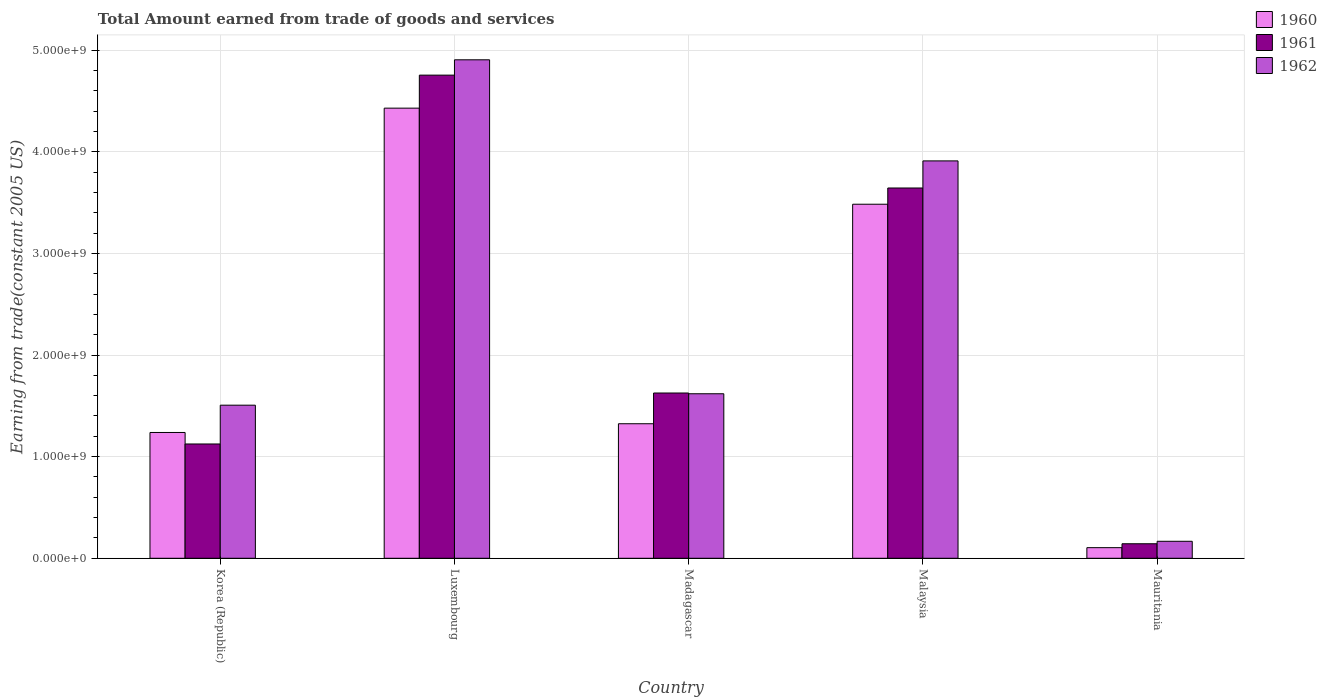How many different coloured bars are there?
Your answer should be very brief. 3. Are the number of bars on each tick of the X-axis equal?
Give a very brief answer. Yes. How many bars are there on the 5th tick from the right?
Ensure brevity in your answer.  3. What is the total amount earned by trading goods and services in 1961 in Madagascar?
Make the answer very short. 1.63e+09. Across all countries, what is the maximum total amount earned by trading goods and services in 1960?
Ensure brevity in your answer.  4.43e+09. Across all countries, what is the minimum total amount earned by trading goods and services in 1960?
Your response must be concise. 1.04e+08. In which country was the total amount earned by trading goods and services in 1961 maximum?
Make the answer very short. Luxembourg. In which country was the total amount earned by trading goods and services in 1962 minimum?
Provide a short and direct response. Mauritania. What is the total total amount earned by trading goods and services in 1961 in the graph?
Provide a succinct answer. 1.13e+1. What is the difference between the total amount earned by trading goods and services in 1962 in Korea (Republic) and that in Mauritania?
Offer a terse response. 1.34e+09. What is the difference between the total amount earned by trading goods and services in 1961 in Mauritania and the total amount earned by trading goods and services in 1962 in Luxembourg?
Offer a very short reply. -4.76e+09. What is the average total amount earned by trading goods and services in 1961 per country?
Keep it short and to the point. 2.26e+09. What is the difference between the total amount earned by trading goods and services of/in 1961 and total amount earned by trading goods and services of/in 1962 in Malaysia?
Your answer should be compact. -2.67e+08. In how many countries, is the total amount earned by trading goods and services in 1960 greater than 4400000000 US$?
Offer a terse response. 1. What is the ratio of the total amount earned by trading goods and services in 1962 in Korea (Republic) to that in Madagascar?
Ensure brevity in your answer.  0.93. Is the total amount earned by trading goods and services in 1960 in Luxembourg less than that in Mauritania?
Make the answer very short. No. Is the difference between the total amount earned by trading goods and services in 1961 in Madagascar and Mauritania greater than the difference between the total amount earned by trading goods and services in 1962 in Madagascar and Mauritania?
Ensure brevity in your answer.  Yes. What is the difference between the highest and the second highest total amount earned by trading goods and services in 1960?
Keep it short and to the point. -9.45e+08. What is the difference between the highest and the lowest total amount earned by trading goods and services in 1960?
Offer a very short reply. 4.32e+09. In how many countries, is the total amount earned by trading goods and services in 1961 greater than the average total amount earned by trading goods and services in 1961 taken over all countries?
Make the answer very short. 2. Is the sum of the total amount earned by trading goods and services in 1960 in Korea (Republic) and Luxembourg greater than the maximum total amount earned by trading goods and services in 1962 across all countries?
Your response must be concise. Yes. What does the 2nd bar from the right in Madagascar represents?
Give a very brief answer. 1961. Is it the case that in every country, the sum of the total amount earned by trading goods and services in 1960 and total amount earned by trading goods and services in 1961 is greater than the total amount earned by trading goods and services in 1962?
Keep it short and to the point. Yes. How many bars are there?
Make the answer very short. 15. Are all the bars in the graph horizontal?
Offer a terse response. No. How many countries are there in the graph?
Keep it short and to the point. 5. Where does the legend appear in the graph?
Provide a short and direct response. Top right. How are the legend labels stacked?
Your answer should be compact. Vertical. What is the title of the graph?
Your answer should be very brief. Total Amount earned from trade of goods and services. Does "1998" appear as one of the legend labels in the graph?
Give a very brief answer. No. What is the label or title of the X-axis?
Make the answer very short. Country. What is the label or title of the Y-axis?
Provide a succinct answer. Earning from trade(constant 2005 US). What is the Earning from trade(constant 2005 US) of 1960 in Korea (Republic)?
Provide a succinct answer. 1.24e+09. What is the Earning from trade(constant 2005 US) of 1961 in Korea (Republic)?
Your answer should be compact. 1.12e+09. What is the Earning from trade(constant 2005 US) in 1962 in Korea (Republic)?
Your answer should be very brief. 1.51e+09. What is the Earning from trade(constant 2005 US) of 1960 in Luxembourg?
Make the answer very short. 4.43e+09. What is the Earning from trade(constant 2005 US) of 1961 in Luxembourg?
Ensure brevity in your answer.  4.75e+09. What is the Earning from trade(constant 2005 US) in 1962 in Luxembourg?
Give a very brief answer. 4.90e+09. What is the Earning from trade(constant 2005 US) of 1960 in Madagascar?
Offer a terse response. 1.32e+09. What is the Earning from trade(constant 2005 US) of 1961 in Madagascar?
Make the answer very short. 1.63e+09. What is the Earning from trade(constant 2005 US) in 1962 in Madagascar?
Your response must be concise. 1.62e+09. What is the Earning from trade(constant 2005 US) in 1960 in Malaysia?
Offer a very short reply. 3.48e+09. What is the Earning from trade(constant 2005 US) of 1961 in Malaysia?
Your answer should be very brief. 3.64e+09. What is the Earning from trade(constant 2005 US) in 1962 in Malaysia?
Give a very brief answer. 3.91e+09. What is the Earning from trade(constant 2005 US) of 1960 in Mauritania?
Your response must be concise. 1.04e+08. What is the Earning from trade(constant 2005 US) in 1961 in Mauritania?
Provide a succinct answer. 1.43e+08. What is the Earning from trade(constant 2005 US) in 1962 in Mauritania?
Keep it short and to the point. 1.67e+08. Across all countries, what is the maximum Earning from trade(constant 2005 US) of 1960?
Your response must be concise. 4.43e+09. Across all countries, what is the maximum Earning from trade(constant 2005 US) of 1961?
Your answer should be compact. 4.75e+09. Across all countries, what is the maximum Earning from trade(constant 2005 US) of 1962?
Offer a terse response. 4.90e+09. Across all countries, what is the minimum Earning from trade(constant 2005 US) in 1960?
Ensure brevity in your answer.  1.04e+08. Across all countries, what is the minimum Earning from trade(constant 2005 US) of 1961?
Your answer should be very brief. 1.43e+08. Across all countries, what is the minimum Earning from trade(constant 2005 US) in 1962?
Your answer should be very brief. 1.67e+08. What is the total Earning from trade(constant 2005 US) of 1960 in the graph?
Your answer should be compact. 1.06e+1. What is the total Earning from trade(constant 2005 US) of 1961 in the graph?
Ensure brevity in your answer.  1.13e+1. What is the total Earning from trade(constant 2005 US) of 1962 in the graph?
Offer a very short reply. 1.21e+1. What is the difference between the Earning from trade(constant 2005 US) in 1960 in Korea (Republic) and that in Luxembourg?
Provide a short and direct response. -3.19e+09. What is the difference between the Earning from trade(constant 2005 US) in 1961 in Korea (Republic) and that in Luxembourg?
Your answer should be very brief. -3.63e+09. What is the difference between the Earning from trade(constant 2005 US) of 1962 in Korea (Republic) and that in Luxembourg?
Provide a succinct answer. -3.40e+09. What is the difference between the Earning from trade(constant 2005 US) in 1960 in Korea (Republic) and that in Madagascar?
Ensure brevity in your answer.  -8.60e+07. What is the difference between the Earning from trade(constant 2005 US) of 1961 in Korea (Republic) and that in Madagascar?
Your response must be concise. -5.02e+08. What is the difference between the Earning from trade(constant 2005 US) of 1962 in Korea (Republic) and that in Madagascar?
Your answer should be compact. -1.12e+08. What is the difference between the Earning from trade(constant 2005 US) of 1960 in Korea (Republic) and that in Malaysia?
Ensure brevity in your answer.  -2.25e+09. What is the difference between the Earning from trade(constant 2005 US) of 1961 in Korea (Republic) and that in Malaysia?
Provide a succinct answer. -2.52e+09. What is the difference between the Earning from trade(constant 2005 US) in 1962 in Korea (Republic) and that in Malaysia?
Ensure brevity in your answer.  -2.40e+09. What is the difference between the Earning from trade(constant 2005 US) of 1960 in Korea (Republic) and that in Mauritania?
Your answer should be compact. 1.13e+09. What is the difference between the Earning from trade(constant 2005 US) in 1961 in Korea (Republic) and that in Mauritania?
Give a very brief answer. 9.82e+08. What is the difference between the Earning from trade(constant 2005 US) of 1962 in Korea (Republic) and that in Mauritania?
Provide a short and direct response. 1.34e+09. What is the difference between the Earning from trade(constant 2005 US) in 1960 in Luxembourg and that in Madagascar?
Offer a very short reply. 3.11e+09. What is the difference between the Earning from trade(constant 2005 US) in 1961 in Luxembourg and that in Madagascar?
Offer a terse response. 3.13e+09. What is the difference between the Earning from trade(constant 2005 US) in 1962 in Luxembourg and that in Madagascar?
Your answer should be compact. 3.29e+09. What is the difference between the Earning from trade(constant 2005 US) in 1960 in Luxembourg and that in Malaysia?
Provide a succinct answer. 9.45e+08. What is the difference between the Earning from trade(constant 2005 US) of 1961 in Luxembourg and that in Malaysia?
Your response must be concise. 1.11e+09. What is the difference between the Earning from trade(constant 2005 US) in 1962 in Luxembourg and that in Malaysia?
Your answer should be very brief. 9.95e+08. What is the difference between the Earning from trade(constant 2005 US) of 1960 in Luxembourg and that in Mauritania?
Provide a succinct answer. 4.32e+09. What is the difference between the Earning from trade(constant 2005 US) of 1961 in Luxembourg and that in Mauritania?
Offer a terse response. 4.61e+09. What is the difference between the Earning from trade(constant 2005 US) of 1962 in Luxembourg and that in Mauritania?
Your answer should be compact. 4.74e+09. What is the difference between the Earning from trade(constant 2005 US) of 1960 in Madagascar and that in Malaysia?
Give a very brief answer. -2.16e+09. What is the difference between the Earning from trade(constant 2005 US) in 1961 in Madagascar and that in Malaysia?
Keep it short and to the point. -2.02e+09. What is the difference between the Earning from trade(constant 2005 US) of 1962 in Madagascar and that in Malaysia?
Provide a succinct answer. -2.29e+09. What is the difference between the Earning from trade(constant 2005 US) of 1960 in Madagascar and that in Mauritania?
Offer a terse response. 1.22e+09. What is the difference between the Earning from trade(constant 2005 US) in 1961 in Madagascar and that in Mauritania?
Your response must be concise. 1.48e+09. What is the difference between the Earning from trade(constant 2005 US) in 1962 in Madagascar and that in Mauritania?
Give a very brief answer. 1.45e+09. What is the difference between the Earning from trade(constant 2005 US) in 1960 in Malaysia and that in Mauritania?
Provide a succinct answer. 3.38e+09. What is the difference between the Earning from trade(constant 2005 US) in 1961 in Malaysia and that in Mauritania?
Provide a short and direct response. 3.50e+09. What is the difference between the Earning from trade(constant 2005 US) of 1962 in Malaysia and that in Mauritania?
Give a very brief answer. 3.74e+09. What is the difference between the Earning from trade(constant 2005 US) of 1960 in Korea (Republic) and the Earning from trade(constant 2005 US) of 1961 in Luxembourg?
Provide a short and direct response. -3.52e+09. What is the difference between the Earning from trade(constant 2005 US) of 1960 in Korea (Republic) and the Earning from trade(constant 2005 US) of 1962 in Luxembourg?
Make the answer very short. -3.67e+09. What is the difference between the Earning from trade(constant 2005 US) in 1961 in Korea (Republic) and the Earning from trade(constant 2005 US) in 1962 in Luxembourg?
Keep it short and to the point. -3.78e+09. What is the difference between the Earning from trade(constant 2005 US) in 1960 in Korea (Republic) and the Earning from trade(constant 2005 US) in 1961 in Madagascar?
Give a very brief answer. -3.88e+08. What is the difference between the Earning from trade(constant 2005 US) of 1960 in Korea (Republic) and the Earning from trade(constant 2005 US) of 1962 in Madagascar?
Offer a very short reply. -3.81e+08. What is the difference between the Earning from trade(constant 2005 US) of 1961 in Korea (Republic) and the Earning from trade(constant 2005 US) of 1962 in Madagascar?
Ensure brevity in your answer.  -4.94e+08. What is the difference between the Earning from trade(constant 2005 US) of 1960 in Korea (Republic) and the Earning from trade(constant 2005 US) of 1961 in Malaysia?
Keep it short and to the point. -2.41e+09. What is the difference between the Earning from trade(constant 2005 US) of 1960 in Korea (Republic) and the Earning from trade(constant 2005 US) of 1962 in Malaysia?
Offer a terse response. -2.67e+09. What is the difference between the Earning from trade(constant 2005 US) in 1961 in Korea (Republic) and the Earning from trade(constant 2005 US) in 1962 in Malaysia?
Your response must be concise. -2.79e+09. What is the difference between the Earning from trade(constant 2005 US) of 1960 in Korea (Republic) and the Earning from trade(constant 2005 US) of 1961 in Mauritania?
Provide a short and direct response. 1.09e+09. What is the difference between the Earning from trade(constant 2005 US) of 1960 in Korea (Republic) and the Earning from trade(constant 2005 US) of 1962 in Mauritania?
Provide a short and direct response. 1.07e+09. What is the difference between the Earning from trade(constant 2005 US) in 1961 in Korea (Republic) and the Earning from trade(constant 2005 US) in 1962 in Mauritania?
Ensure brevity in your answer.  9.58e+08. What is the difference between the Earning from trade(constant 2005 US) in 1960 in Luxembourg and the Earning from trade(constant 2005 US) in 1961 in Madagascar?
Ensure brevity in your answer.  2.80e+09. What is the difference between the Earning from trade(constant 2005 US) in 1960 in Luxembourg and the Earning from trade(constant 2005 US) in 1962 in Madagascar?
Provide a succinct answer. 2.81e+09. What is the difference between the Earning from trade(constant 2005 US) in 1961 in Luxembourg and the Earning from trade(constant 2005 US) in 1962 in Madagascar?
Provide a succinct answer. 3.14e+09. What is the difference between the Earning from trade(constant 2005 US) in 1960 in Luxembourg and the Earning from trade(constant 2005 US) in 1961 in Malaysia?
Your response must be concise. 7.86e+08. What is the difference between the Earning from trade(constant 2005 US) in 1960 in Luxembourg and the Earning from trade(constant 2005 US) in 1962 in Malaysia?
Provide a short and direct response. 5.19e+08. What is the difference between the Earning from trade(constant 2005 US) in 1961 in Luxembourg and the Earning from trade(constant 2005 US) in 1962 in Malaysia?
Provide a short and direct response. 8.44e+08. What is the difference between the Earning from trade(constant 2005 US) of 1960 in Luxembourg and the Earning from trade(constant 2005 US) of 1961 in Mauritania?
Ensure brevity in your answer.  4.29e+09. What is the difference between the Earning from trade(constant 2005 US) in 1960 in Luxembourg and the Earning from trade(constant 2005 US) in 1962 in Mauritania?
Provide a succinct answer. 4.26e+09. What is the difference between the Earning from trade(constant 2005 US) of 1961 in Luxembourg and the Earning from trade(constant 2005 US) of 1962 in Mauritania?
Make the answer very short. 4.59e+09. What is the difference between the Earning from trade(constant 2005 US) of 1960 in Madagascar and the Earning from trade(constant 2005 US) of 1961 in Malaysia?
Your answer should be very brief. -2.32e+09. What is the difference between the Earning from trade(constant 2005 US) of 1960 in Madagascar and the Earning from trade(constant 2005 US) of 1962 in Malaysia?
Make the answer very short. -2.59e+09. What is the difference between the Earning from trade(constant 2005 US) in 1961 in Madagascar and the Earning from trade(constant 2005 US) in 1962 in Malaysia?
Your answer should be very brief. -2.28e+09. What is the difference between the Earning from trade(constant 2005 US) in 1960 in Madagascar and the Earning from trade(constant 2005 US) in 1961 in Mauritania?
Your answer should be very brief. 1.18e+09. What is the difference between the Earning from trade(constant 2005 US) in 1960 in Madagascar and the Earning from trade(constant 2005 US) in 1962 in Mauritania?
Ensure brevity in your answer.  1.16e+09. What is the difference between the Earning from trade(constant 2005 US) of 1961 in Madagascar and the Earning from trade(constant 2005 US) of 1962 in Mauritania?
Your answer should be compact. 1.46e+09. What is the difference between the Earning from trade(constant 2005 US) in 1960 in Malaysia and the Earning from trade(constant 2005 US) in 1961 in Mauritania?
Your answer should be compact. 3.34e+09. What is the difference between the Earning from trade(constant 2005 US) of 1960 in Malaysia and the Earning from trade(constant 2005 US) of 1962 in Mauritania?
Keep it short and to the point. 3.32e+09. What is the difference between the Earning from trade(constant 2005 US) of 1961 in Malaysia and the Earning from trade(constant 2005 US) of 1962 in Mauritania?
Provide a succinct answer. 3.48e+09. What is the average Earning from trade(constant 2005 US) in 1960 per country?
Your response must be concise. 2.12e+09. What is the average Earning from trade(constant 2005 US) in 1961 per country?
Provide a succinct answer. 2.26e+09. What is the average Earning from trade(constant 2005 US) in 1962 per country?
Your response must be concise. 2.42e+09. What is the difference between the Earning from trade(constant 2005 US) in 1960 and Earning from trade(constant 2005 US) in 1961 in Korea (Republic)?
Your answer should be compact. 1.13e+08. What is the difference between the Earning from trade(constant 2005 US) in 1960 and Earning from trade(constant 2005 US) in 1962 in Korea (Republic)?
Keep it short and to the point. -2.69e+08. What is the difference between the Earning from trade(constant 2005 US) in 1961 and Earning from trade(constant 2005 US) in 1962 in Korea (Republic)?
Ensure brevity in your answer.  -3.82e+08. What is the difference between the Earning from trade(constant 2005 US) of 1960 and Earning from trade(constant 2005 US) of 1961 in Luxembourg?
Offer a terse response. -3.25e+08. What is the difference between the Earning from trade(constant 2005 US) in 1960 and Earning from trade(constant 2005 US) in 1962 in Luxembourg?
Ensure brevity in your answer.  -4.76e+08. What is the difference between the Earning from trade(constant 2005 US) in 1961 and Earning from trade(constant 2005 US) in 1962 in Luxembourg?
Give a very brief answer. -1.51e+08. What is the difference between the Earning from trade(constant 2005 US) in 1960 and Earning from trade(constant 2005 US) in 1961 in Madagascar?
Offer a very short reply. -3.02e+08. What is the difference between the Earning from trade(constant 2005 US) in 1960 and Earning from trade(constant 2005 US) in 1962 in Madagascar?
Offer a terse response. -2.95e+08. What is the difference between the Earning from trade(constant 2005 US) in 1961 and Earning from trade(constant 2005 US) in 1962 in Madagascar?
Give a very brief answer. 7.38e+06. What is the difference between the Earning from trade(constant 2005 US) in 1960 and Earning from trade(constant 2005 US) in 1961 in Malaysia?
Keep it short and to the point. -1.60e+08. What is the difference between the Earning from trade(constant 2005 US) of 1960 and Earning from trade(constant 2005 US) of 1962 in Malaysia?
Offer a very short reply. -4.26e+08. What is the difference between the Earning from trade(constant 2005 US) of 1961 and Earning from trade(constant 2005 US) of 1962 in Malaysia?
Your answer should be very brief. -2.67e+08. What is the difference between the Earning from trade(constant 2005 US) of 1960 and Earning from trade(constant 2005 US) of 1961 in Mauritania?
Make the answer very short. -3.85e+07. What is the difference between the Earning from trade(constant 2005 US) in 1960 and Earning from trade(constant 2005 US) in 1962 in Mauritania?
Provide a succinct answer. -6.27e+07. What is the difference between the Earning from trade(constant 2005 US) of 1961 and Earning from trade(constant 2005 US) of 1962 in Mauritania?
Ensure brevity in your answer.  -2.42e+07. What is the ratio of the Earning from trade(constant 2005 US) of 1960 in Korea (Republic) to that in Luxembourg?
Provide a short and direct response. 0.28. What is the ratio of the Earning from trade(constant 2005 US) of 1961 in Korea (Republic) to that in Luxembourg?
Your answer should be very brief. 0.24. What is the ratio of the Earning from trade(constant 2005 US) of 1962 in Korea (Republic) to that in Luxembourg?
Give a very brief answer. 0.31. What is the ratio of the Earning from trade(constant 2005 US) in 1960 in Korea (Republic) to that in Madagascar?
Ensure brevity in your answer.  0.94. What is the ratio of the Earning from trade(constant 2005 US) in 1961 in Korea (Republic) to that in Madagascar?
Your answer should be very brief. 0.69. What is the ratio of the Earning from trade(constant 2005 US) of 1962 in Korea (Republic) to that in Madagascar?
Provide a short and direct response. 0.93. What is the ratio of the Earning from trade(constant 2005 US) of 1960 in Korea (Republic) to that in Malaysia?
Provide a short and direct response. 0.36. What is the ratio of the Earning from trade(constant 2005 US) of 1961 in Korea (Republic) to that in Malaysia?
Ensure brevity in your answer.  0.31. What is the ratio of the Earning from trade(constant 2005 US) of 1962 in Korea (Republic) to that in Malaysia?
Your answer should be very brief. 0.39. What is the ratio of the Earning from trade(constant 2005 US) in 1960 in Korea (Republic) to that in Mauritania?
Provide a short and direct response. 11.86. What is the ratio of the Earning from trade(constant 2005 US) of 1961 in Korea (Republic) to that in Mauritania?
Your answer should be very brief. 7.87. What is the ratio of the Earning from trade(constant 2005 US) of 1962 in Korea (Republic) to that in Mauritania?
Offer a terse response. 9.02. What is the ratio of the Earning from trade(constant 2005 US) of 1960 in Luxembourg to that in Madagascar?
Provide a succinct answer. 3.35. What is the ratio of the Earning from trade(constant 2005 US) in 1961 in Luxembourg to that in Madagascar?
Your response must be concise. 2.92. What is the ratio of the Earning from trade(constant 2005 US) of 1962 in Luxembourg to that in Madagascar?
Offer a terse response. 3.03. What is the ratio of the Earning from trade(constant 2005 US) in 1960 in Luxembourg to that in Malaysia?
Provide a succinct answer. 1.27. What is the ratio of the Earning from trade(constant 2005 US) in 1961 in Luxembourg to that in Malaysia?
Provide a succinct answer. 1.3. What is the ratio of the Earning from trade(constant 2005 US) in 1962 in Luxembourg to that in Malaysia?
Give a very brief answer. 1.25. What is the ratio of the Earning from trade(constant 2005 US) in 1960 in Luxembourg to that in Mauritania?
Offer a terse response. 42.45. What is the ratio of the Earning from trade(constant 2005 US) of 1961 in Luxembourg to that in Mauritania?
Ensure brevity in your answer.  33.28. What is the ratio of the Earning from trade(constant 2005 US) of 1962 in Luxembourg to that in Mauritania?
Provide a succinct answer. 29.37. What is the ratio of the Earning from trade(constant 2005 US) of 1960 in Madagascar to that in Malaysia?
Your answer should be compact. 0.38. What is the ratio of the Earning from trade(constant 2005 US) of 1961 in Madagascar to that in Malaysia?
Ensure brevity in your answer.  0.45. What is the ratio of the Earning from trade(constant 2005 US) in 1962 in Madagascar to that in Malaysia?
Provide a short and direct response. 0.41. What is the ratio of the Earning from trade(constant 2005 US) of 1960 in Madagascar to that in Mauritania?
Keep it short and to the point. 12.69. What is the ratio of the Earning from trade(constant 2005 US) in 1961 in Madagascar to that in Mauritania?
Offer a very short reply. 11.38. What is the ratio of the Earning from trade(constant 2005 US) of 1962 in Madagascar to that in Mauritania?
Offer a very short reply. 9.69. What is the ratio of the Earning from trade(constant 2005 US) in 1960 in Malaysia to that in Mauritania?
Ensure brevity in your answer.  33.39. What is the ratio of the Earning from trade(constant 2005 US) of 1961 in Malaysia to that in Mauritania?
Keep it short and to the point. 25.51. What is the ratio of the Earning from trade(constant 2005 US) in 1962 in Malaysia to that in Mauritania?
Make the answer very short. 23.41. What is the difference between the highest and the second highest Earning from trade(constant 2005 US) in 1960?
Ensure brevity in your answer.  9.45e+08. What is the difference between the highest and the second highest Earning from trade(constant 2005 US) in 1961?
Your response must be concise. 1.11e+09. What is the difference between the highest and the second highest Earning from trade(constant 2005 US) of 1962?
Keep it short and to the point. 9.95e+08. What is the difference between the highest and the lowest Earning from trade(constant 2005 US) in 1960?
Ensure brevity in your answer.  4.32e+09. What is the difference between the highest and the lowest Earning from trade(constant 2005 US) of 1961?
Your answer should be compact. 4.61e+09. What is the difference between the highest and the lowest Earning from trade(constant 2005 US) of 1962?
Your answer should be compact. 4.74e+09. 